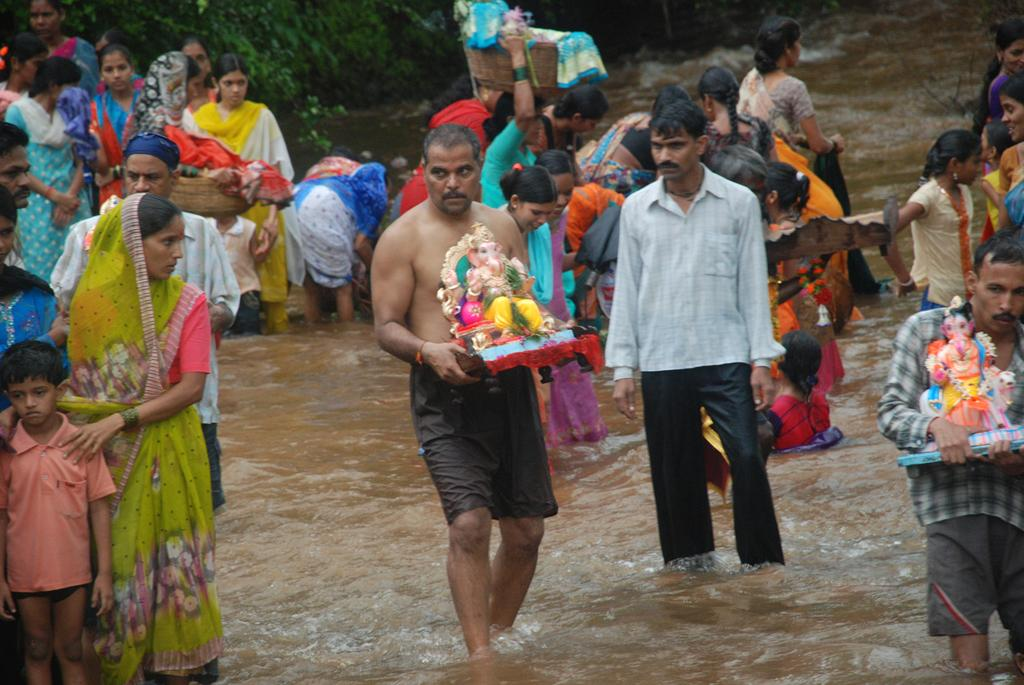What is the main subject of the image? The main subject of the image is a person standing in the middle. What is the person holding in the image? The person is holding Lord Ganesha. What type of hook can be seen in the image? There is no hook present in the image. What force is being applied by the person holding Lord Ganesha? The image does not provide information about any force being applied by the person holding Lord Ganesha. 